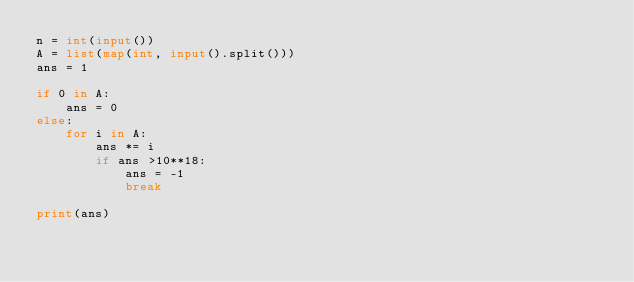Convert code to text. <code><loc_0><loc_0><loc_500><loc_500><_Python_>n = int(input())
A = list(map(int, input().split()))
ans = 1

if 0 in A:
    ans = 0
else:
    for i in A:
        ans *= i
        if ans >10**18:
            ans = -1
            break
        
print(ans)
</code> 